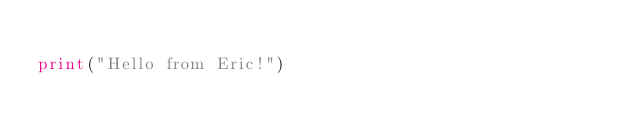<code> <loc_0><loc_0><loc_500><loc_500><_Python_>
print("Hello from Eric!")</code> 